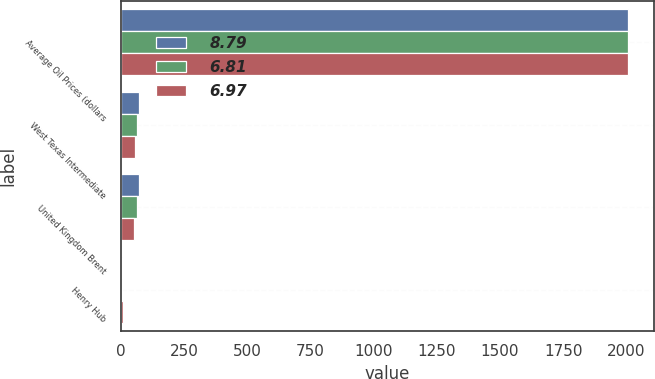<chart> <loc_0><loc_0><loc_500><loc_500><stacked_bar_chart><ecel><fcel>Average Oil Prices (dollars<fcel>West Texas Intermediate<fcel>United Kingdom Brent<fcel>Henry Hub<nl><fcel>8.79<fcel>2007<fcel>71.91<fcel>72.21<fcel>6.97<nl><fcel>6.81<fcel>2006<fcel>66.17<fcel>65.35<fcel>6.81<nl><fcel>6.97<fcel>2005<fcel>56.3<fcel>54.45<fcel>8.79<nl></chart> 